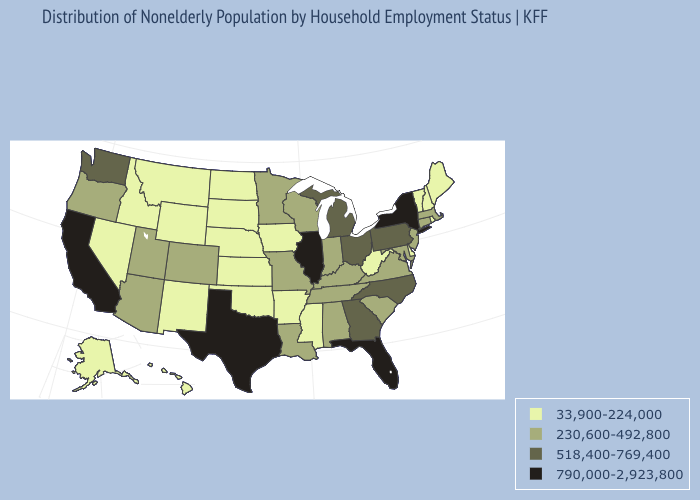Which states have the lowest value in the MidWest?
Answer briefly. Iowa, Kansas, Nebraska, North Dakota, South Dakota. Does Minnesota have a lower value than Kansas?
Concise answer only. No. What is the lowest value in the MidWest?
Give a very brief answer. 33,900-224,000. Does South Dakota have the same value as Arkansas?
Short answer required. Yes. What is the value of Nevada?
Answer briefly. 33,900-224,000. What is the highest value in the West ?
Give a very brief answer. 790,000-2,923,800. What is the value of Minnesota?
Short answer required. 230,600-492,800. Is the legend a continuous bar?
Short answer required. No. Name the states that have a value in the range 230,600-492,800?
Be succinct. Alabama, Arizona, Colorado, Connecticut, Indiana, Kentucky, Louisiana, Maryland, Massachusetts, Minnesota, Missouri, New Jersey, Oregon, South Carolina, Tennessee, Utah, Virginia, Wisconsin. Which states hav the highest value in the MidWest?
Short answer required. Illinois. Which states hav the highest value in the Northeast?
Keep it brief. New York. What is the value of Virginia?
Concise answer only. 230,600-492,800. What is the highest value in the MidWest ?
Write a very short answer. 790,000-2,923,800. Among the states that border Virginia , does Kentucky have the highest value?
Answer briefly. No. Name the states that have a value in the range 518,400-769,400?
Short answer required. Georgia, Michigan, North Carolina, Ohio, Pennsylvania, Washington. 